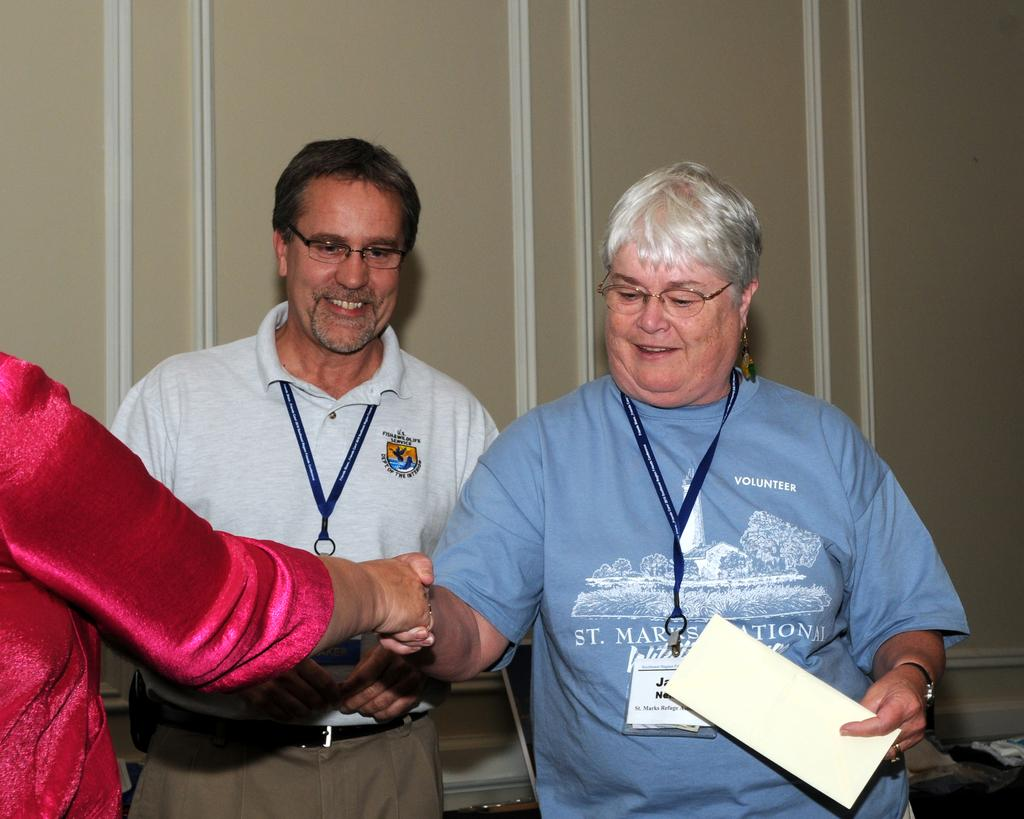Who are the main subjects in the image? There are two persons with glasses in the center of the image. What are the expressions on their faces? The two persons are smiling. What are the positions of the two persons in the image? The two persons are standing. Can you describe the background of the image? There is a wall in the background of the image. Are there any other people visible in the image? Yes, there is another person on the left side of the image. What type of stick is being used to hold up the earth in the image? There is no stick or earth present in the image; it features two persons with glasses and another person standing nearby. What is the iron content of the glasses worn by the two persons in the image? The image does not provide information about the iron content of the glasses worn by the two persons. 